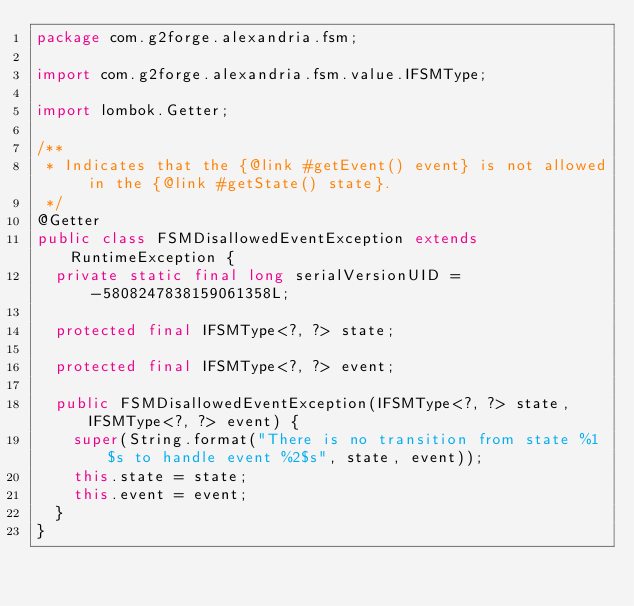<code> <loc_0><loc_0><loc_500><loc_500><_Java_>package com.g2forge.alexandria.fsm;

import com.g2forge.alexandria.fsm.value.IFSMType;

import lombok.Getter;

/**
 * Indicates that the {@link #getEvent() event} is not allowed in the {@link #getState() state}.
 */
@Getter
public class FSMDisallowedEventException extends RuntimeException {
	private static final long serialVersionUID = -5808247838159061358L;

	protected final IFSMType<?, ?> state;

	protected final IFSMType<?, ?> event;

	public FSMDisallowedEventException(IFSMType<?, ?> state, IFSMType<?, ?> event) {
		super(String.format("There is no transition from state %1$s to handle event %2$s", state, event));
		this.state = state;
		this.event = event;
	}
}
</code> 